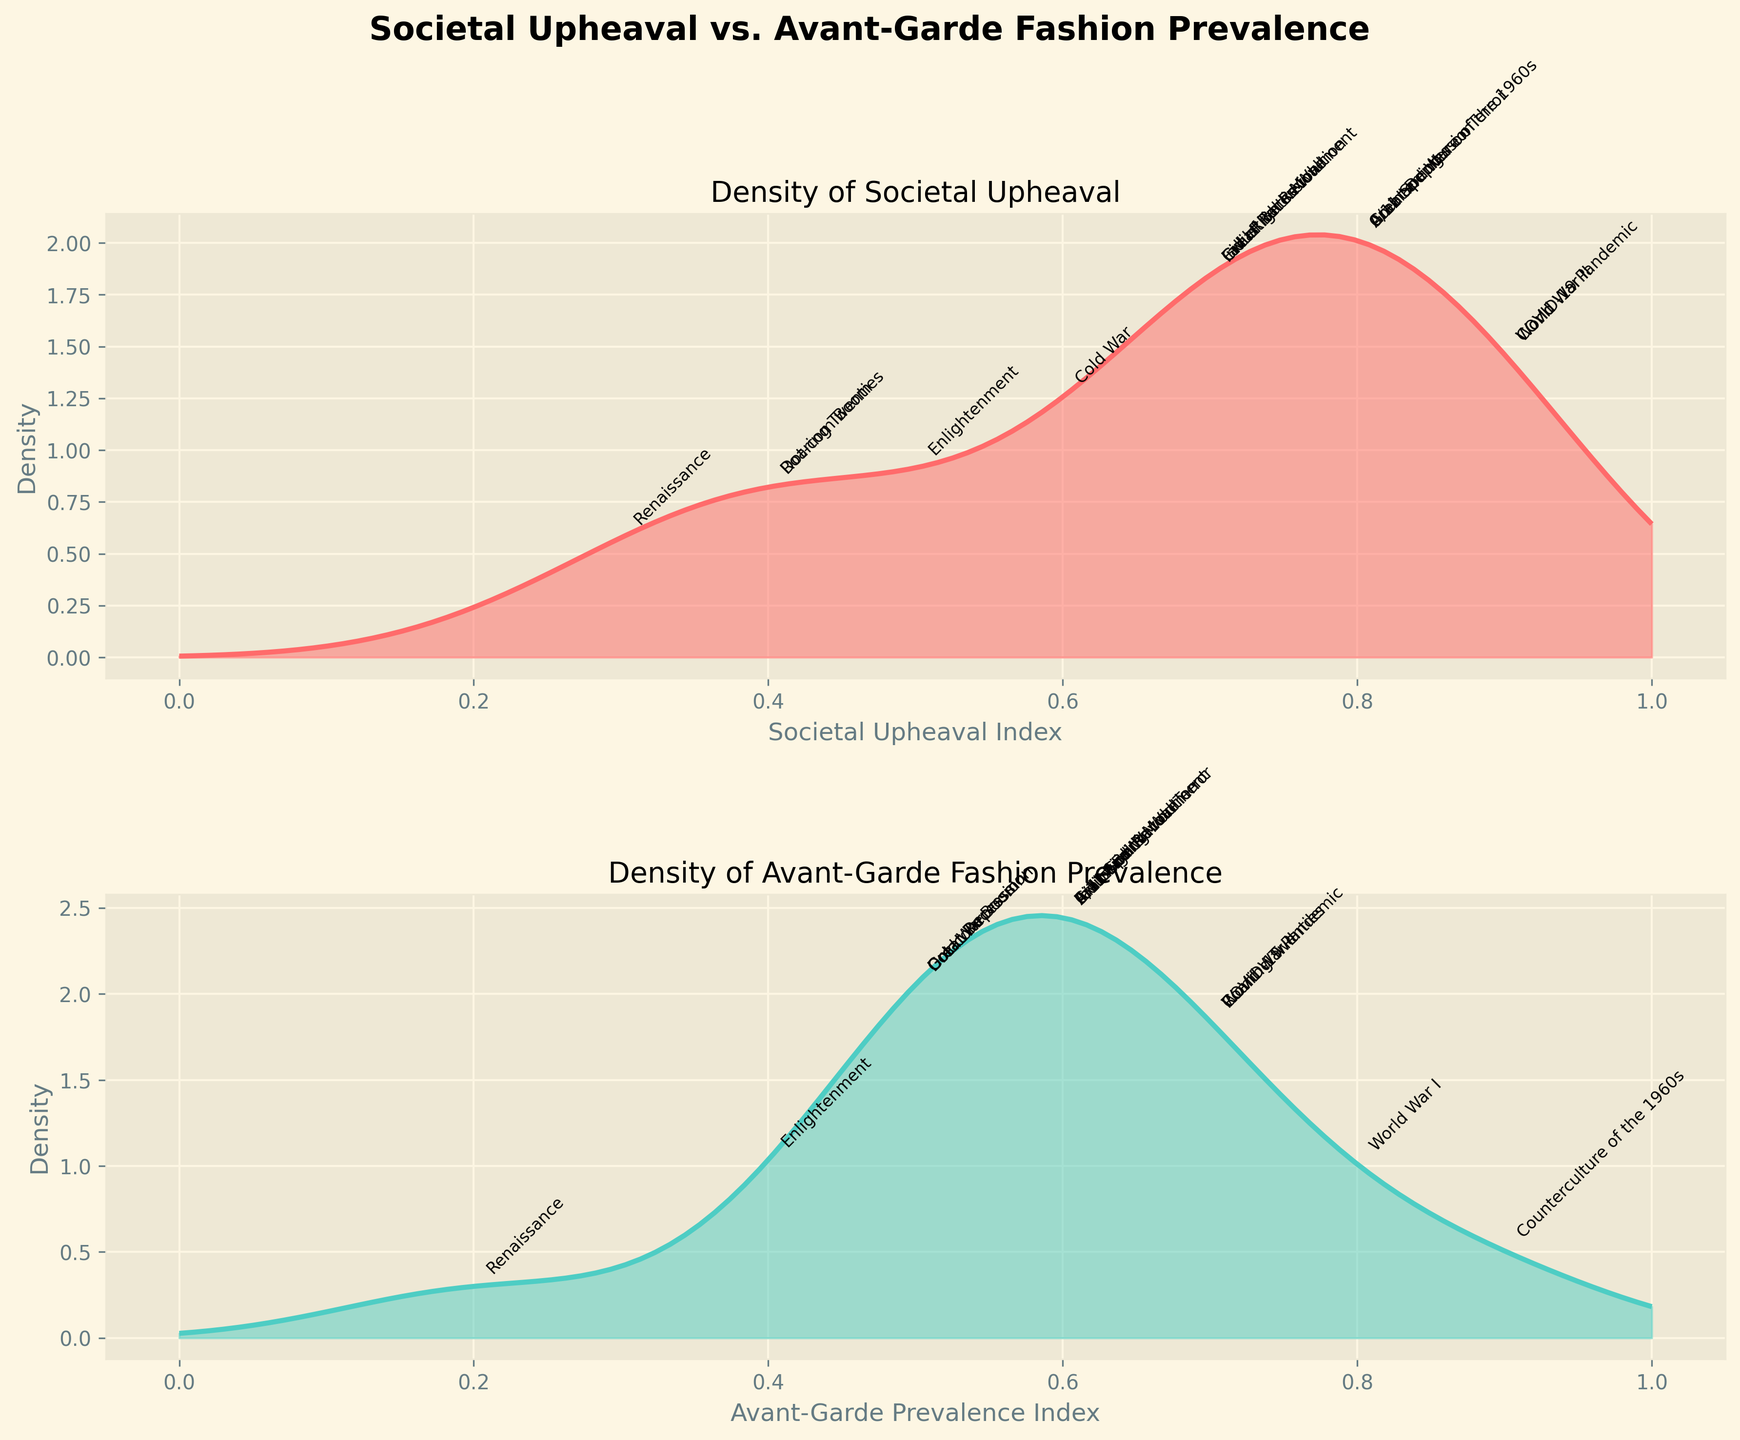What is the title of the overall figure? The title of the overall figure can be found at the top and it reads "Societal Upheaval vs. Avant-Garde Fashion Prevalence". This can be seen in bold and large font size.
Answer: Societal Upheaval vs. Avant-Garde Fashion Prevalence What is the axis label for the x-axis of the first subplot? The x-axis label for the first subplot can be identified just below it and it reads "Societal Upheaval Index". This describes what is measured along the horizontal axis in the first subplot.
Answer: Societal Upheaval Index What is the color of the density plot for Avant-Garde Fashion Prevalence? The color of the density plot for Avant-Garde Fashion Prevalence is a shade of teal. This color is used for the line and the filled-in area under the curve in the second subplot.
Answer: teal Which historical period has the highest point on the density plot for Societal Upheaval? To determine the historical period with the highest point, look for the peak of the first subplot (Societal Upheaval) and find the annotation near this peak. The period annotated close to the highest density value is "World War I".
Answer: World War I At what point do both density plots (Societal Upheaval and Avant-Garde Prevalence) reach their peaks? Looking at the peaks of both subplots, the highest densities occur close to the values 0.9 for Societal Upheaval and around 0.7 to 0.9 for Avant-Garde Prevalence.
Answer: 0.9 (Societal Upheaval) and around 0.7 to 0.9 (Avant-Garde Prevalence) Which historical periods show both high societal upheaval and avant-garde fashion prevalence? To answer this, look for historical periods that are annotated at higher values in both subplots. Periods like "World War I", "World War II", "Counterculture of the 1960s", and "COVID-19 Pandemic" are annotated at higher values in both subplots.
Answer: World War I, World War II, Counterculture of the 1960s, COVID-19 Pandemic Describe the general trend observed in the density plot of Societal Upheaval. The density plot for Societal Upheaval shows that the highest density is around the 0.9 mark, indicating that higher societal upheaval values are more frequent. Lower values have lesser density.
Answer: Highest density around 0.9 During which historical period is the avant-garde fashion most prevalent while societal upheaval is relatively moderate? From the second subplot, the "Roaring Twenties" has a high avant-garde prevalence. Cross-referencing this with the first subplot shows that during this period, societal upheaval was moderate around the 0.4 index.
Answer: Roaring Twenties What do the density plot shapes reveal about the distribution of societal upheaval and avant-garde fashion prevalence? The shapes of the density plots indicate that societal upheaval is heavily skewed towards high values (around 0.9), while avant-garde fashion prevalence shows a distribution with a prominent peak around 0.7 but has relatively high density over a broader range.
Answer: Societal upheaval is heavily skewed towards high values; avant-garde fashion prevalence has a peak at 0.7 